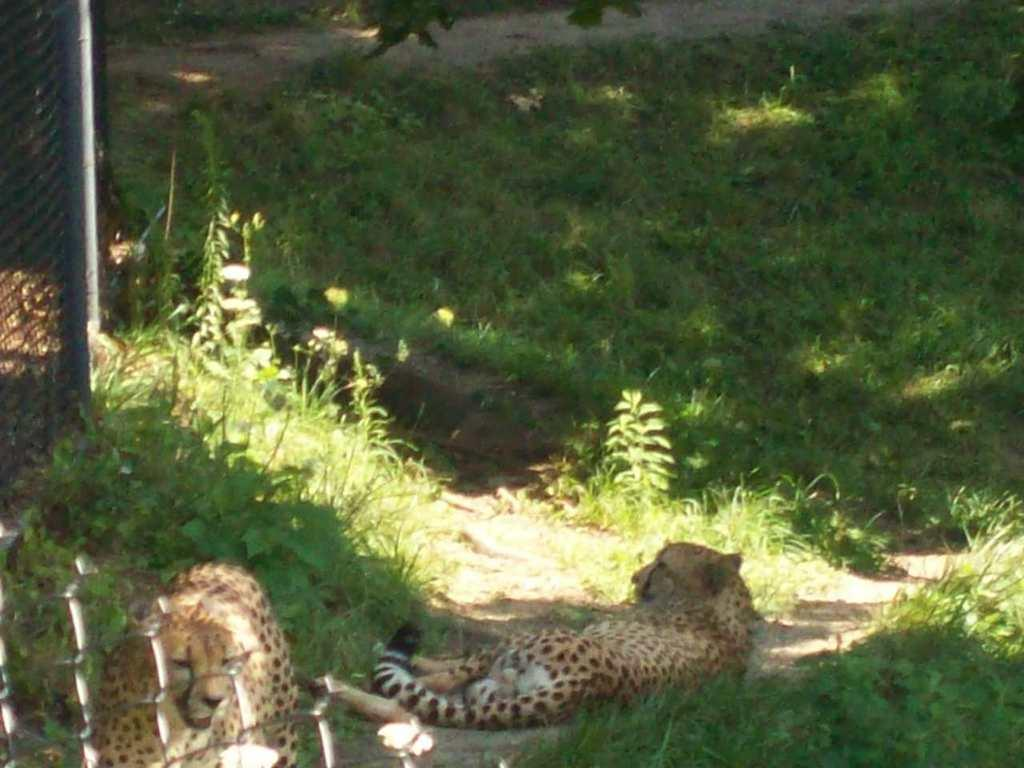What animals are in the center of the image? There are cheetahs in the center of the image. What is located on the left side of the image? There is fencing on the left side of the image. What type of vegetation can be seen in the background of the image? There is grass visible in the background of the image. What type of coast can be seen in the image? There is no coast present in the image; it features cheetahs, fencing, and grass. 